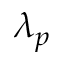<formula> <loc_0><loc_0><loc_500><loc_500>\lambda _ { p }</formula> 